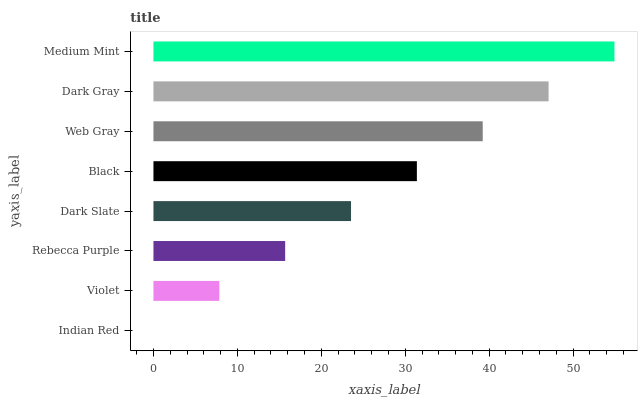Is Indian Red the minimum?
Answer yes or no. Yes. Is Medium Mint the maximum?
Answer yes or no. Yes. Is Violet the minimum?
Answer yes or no. No. Is Violet the maximum?
Answer yes or no. No. Is Violet greater than Indian Red?
Answer yes or no. Yes. Is Indian Red less than Violet?
Answer yes or no. Yes. Is Indian Red greater than Violet?
Answer yes or no. No. Is Violet less than Indian Red?
Answer yes or no. No. Is Black the high median?
Answer yes or no. Yes. Is Dark Slate the low median?
Answer yes or no. Yes. Is Dark Gray the high median?
Answer yes or no. No. Is Web Gray the low median?
Answer yes or no. No. 